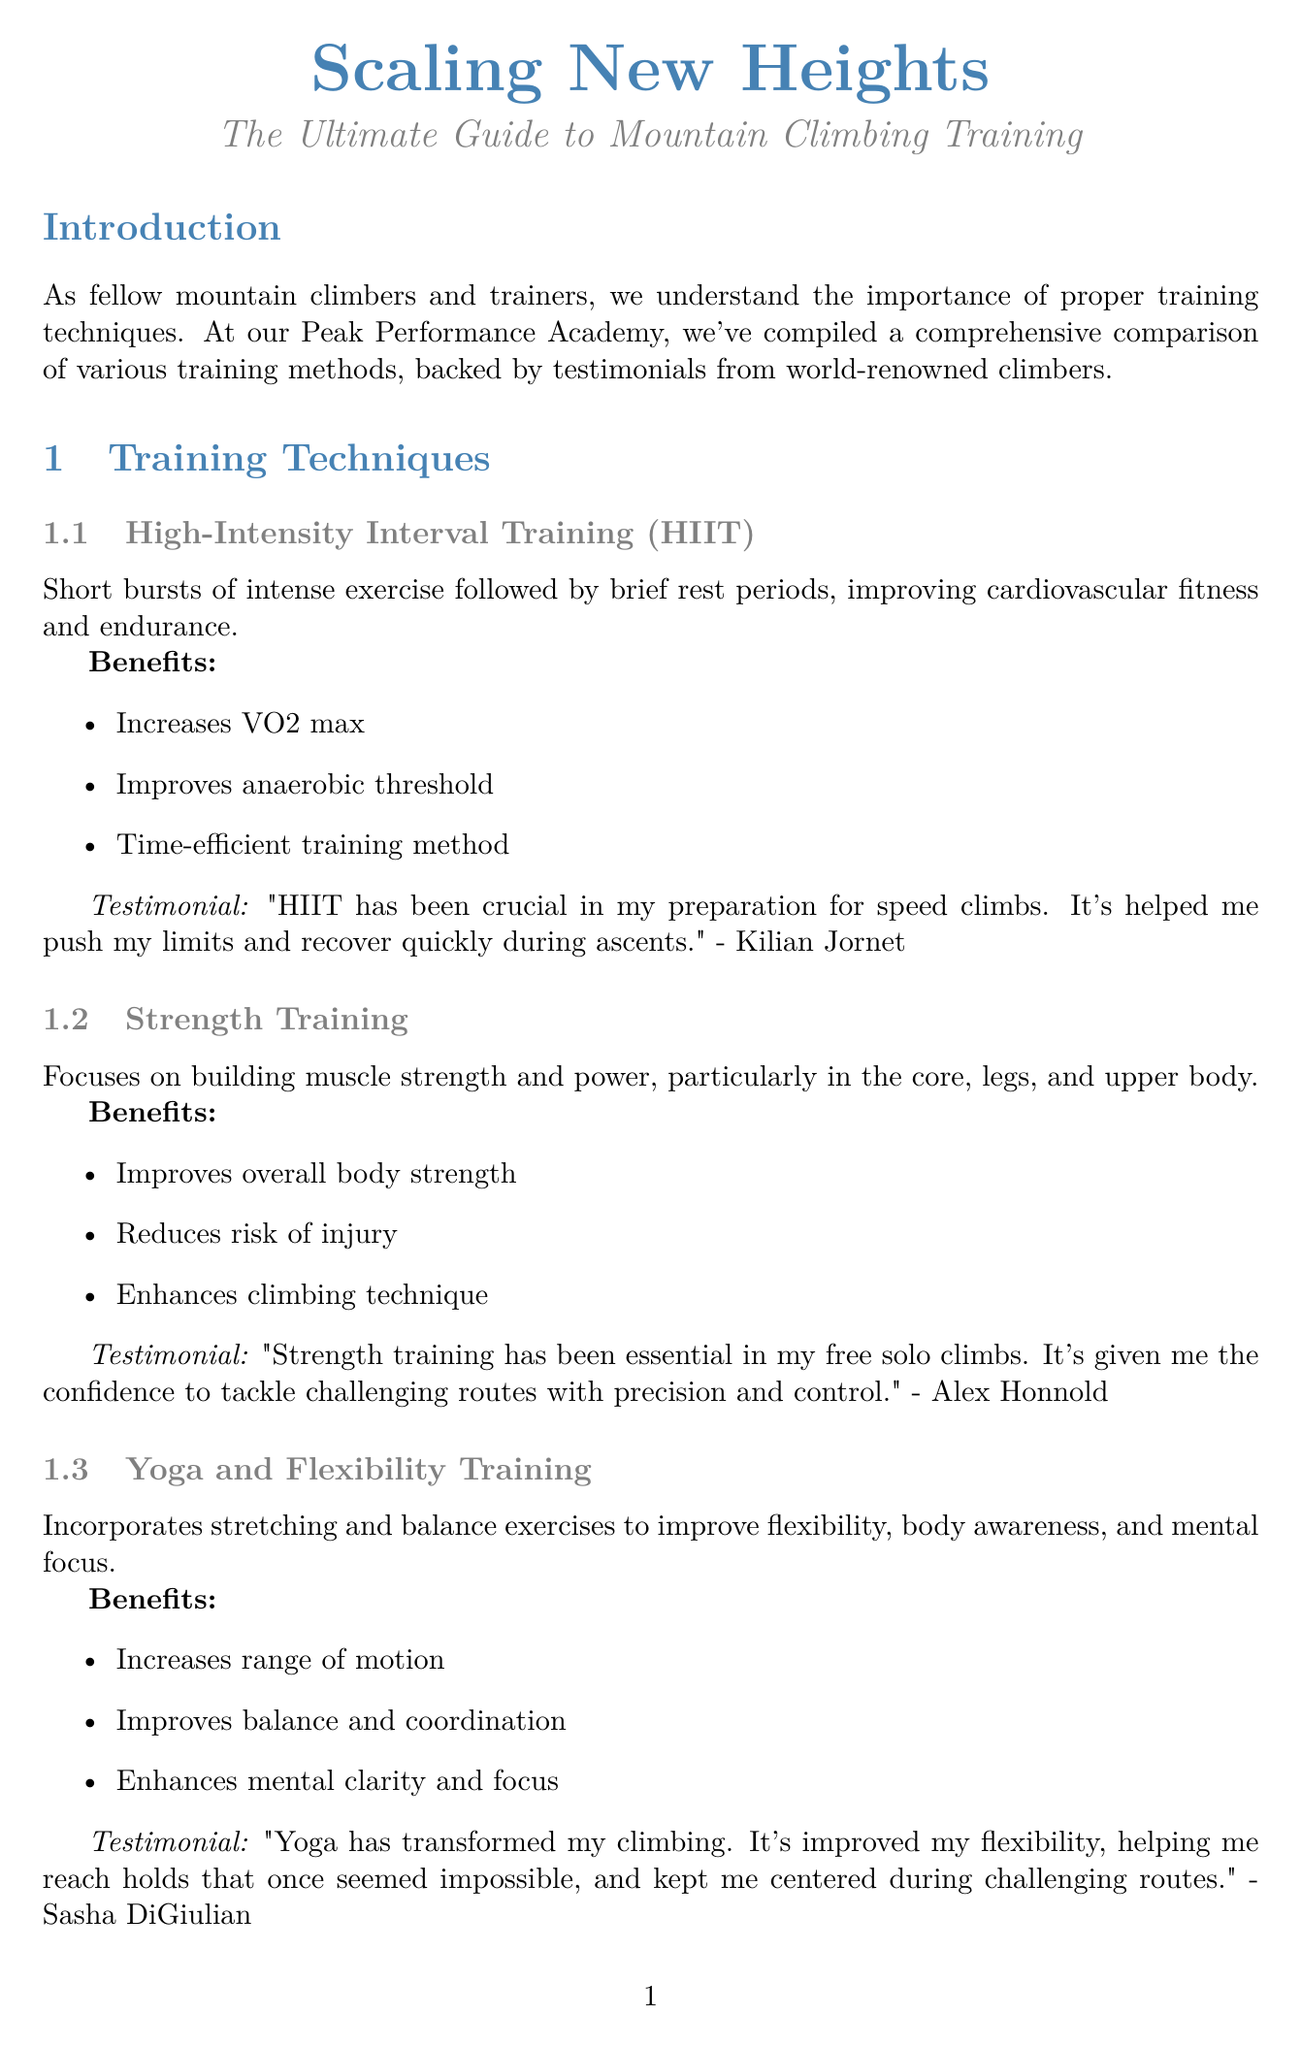what is the title of the newsletter? The title of the newsletter is explicitly stated at the beginning of the document.
Answer: Scaling New Heights: The Ultimate Guide to Mountain Climbing Training who is the climber that provided a testimonial for HIIT? The document lists a specific climber associated with each training technique.
Answer: Kilian Jornet what are the benefits of Yoga and Flexibility Training? The document outlines specific benefits associated with each training technique.
Answer: Increases range of motion, Improves balance and coordination, Enhances mental clarity and focus when is the Advanced Technique Workshop scheduled? The specific date of the event is presented in the upcoming events section.
Answer: July 15-17, 2023 what type of training gear is recommended for improving finger strength? The document provides a description along with a recommended product for each type of training gear.
Answer: Hangboards which climber emphasizes the importance of strength training? The document includes testimonials from climbers that highlight their preferred training methods.
Answer: Alex Honnold what is one nutrition tip mentioned in the newsletter? The document lists various nutrition tips that are crucial for climbing.
Answer: Prioritize complex carbohydrates for sustained energy what is the location for the High Altitude Preparation Course? The location for each event is clearly specified in the upcoming events section.
Answer: Mount Rainier, Washington 